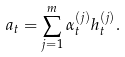<formula> <loc_0><loc_0><loc_500><loc_500>a _ { t } = \sum _ { j = 1 } ^ { m } \alpha ^ { ( j ) } _ { t } h ^ { ( j ) } _ { t } .</formula> 